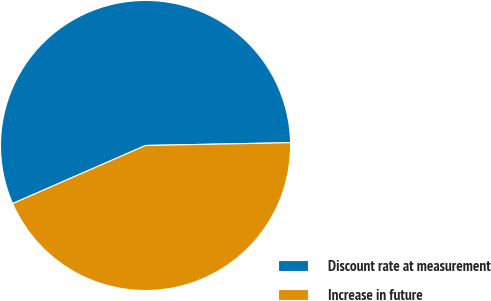<chart> <loc_0><loc_0><loc_500><loc_500><pie_chart><fcel>Discount rate at measurement<fcel>Increase in future<nl><fcel>56.25%<fcel>43.75%<nl></chart> 